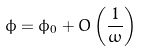<formula> <loc_0><loc_0><loc_500><loc_500>\phi = \phi _ { 0 } + O \left ( \frac { 1 } { \omega } \right )</formula> 